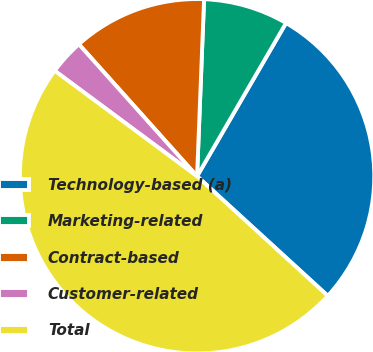Convert chart. <chart><loc_0><loc_0><loc_500><loc_500><pie_chart><fcel>Technology-based (a)<fcel>Marketing-related<fcel>Contract-based<fcel>Customer-related<fcel>Total<nl><fcel>28.42%<fcel>7.74%<fcel>12.25%<fcel>3.23%<fcel>48.35%<nl></chart> 